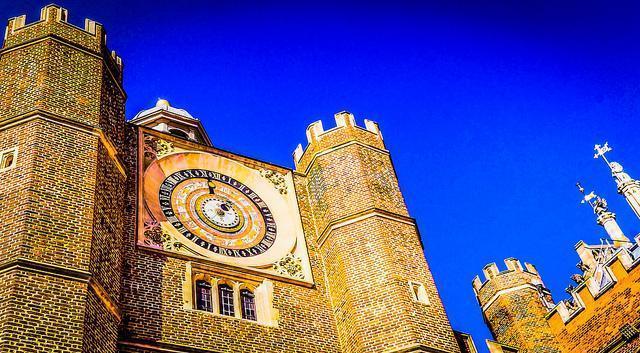How many windows are there?
Give a very brief answer. 5. How many blue trucks are there?
Give a very brief answer. 0. 